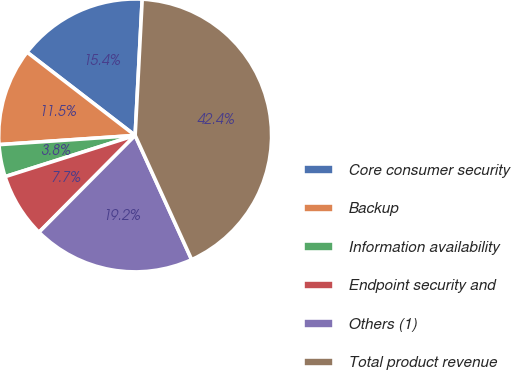Convert chart to OTSL. <chart><loc_0><loc_0><loc_500><loc_500><pie_chart><fcel>Core consumer security<fcel>Backup<fcel>Information availability<fcel>Endpoint security and<fcel>Others (1)<fcel>Total product revenue<nl><fcel>15.38%<fcel>11.52%<fcel>3.81%<fcel>7.67%<fcel>19.24%<fcel>42.38%<nl></chart> 